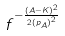<formula> <loc_0><loc_0><loc_500><loc_500>f ^ { - \frac { ( A - K ) ^ { 2 } } { 2 { ( p _ { A } ) } ^ { 2 } } }</formula> 